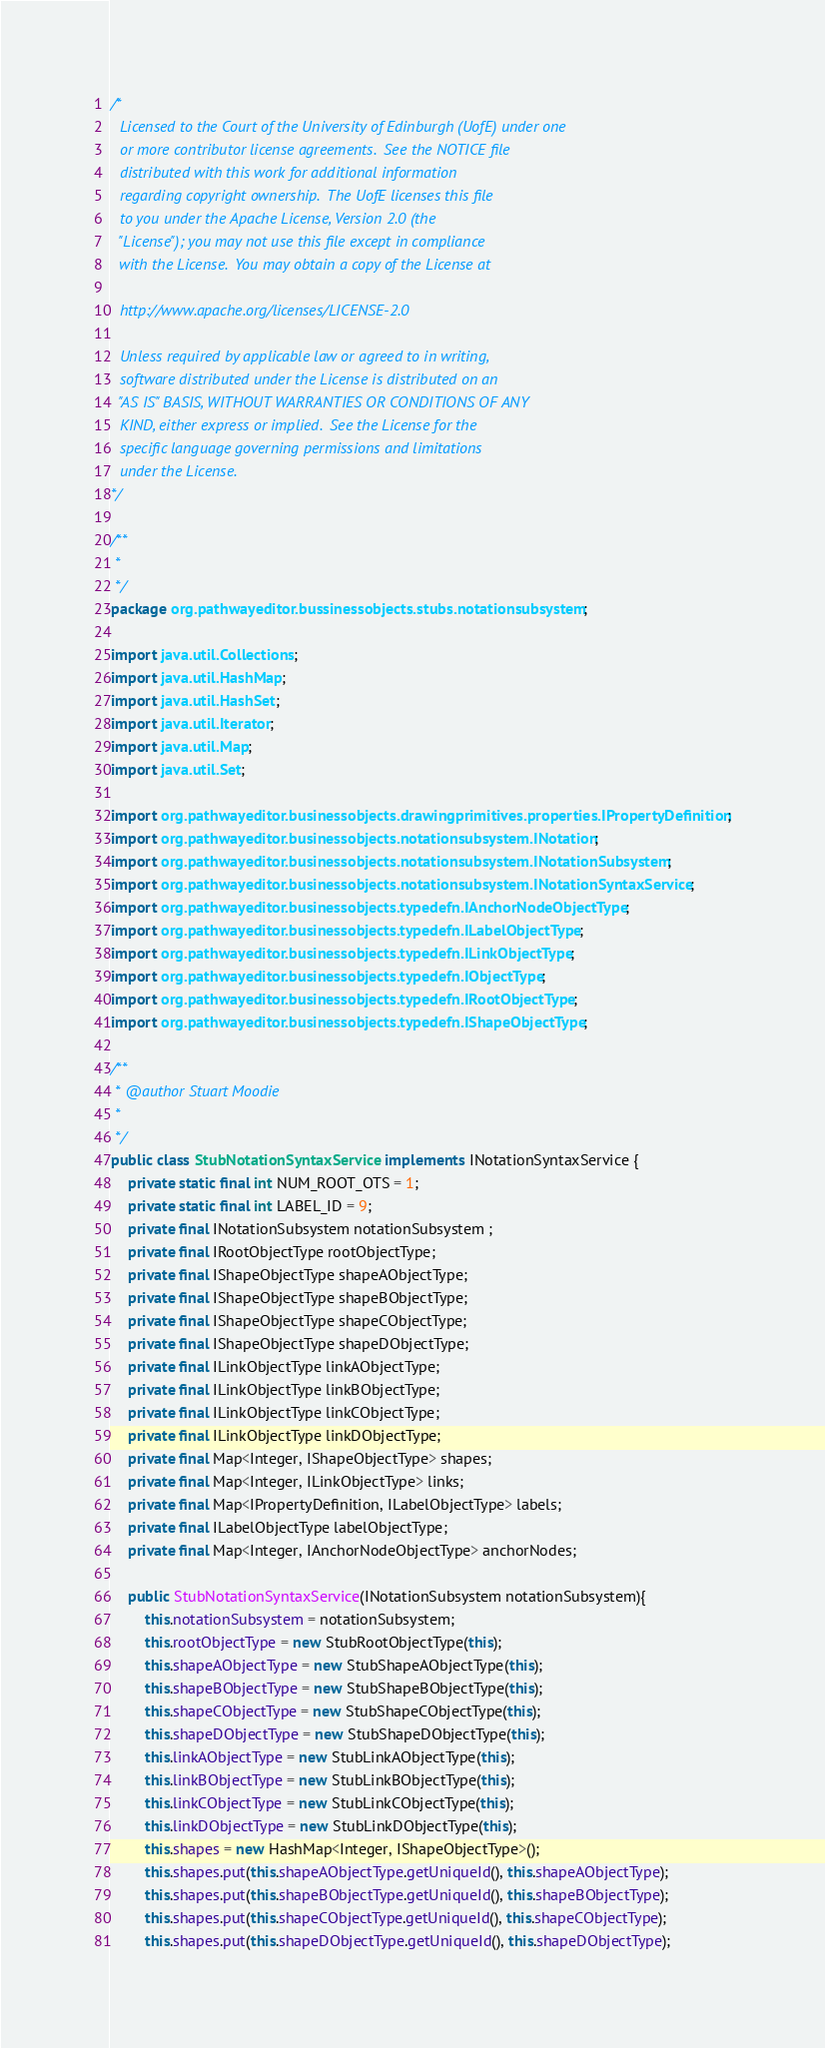Convert code to text. <code><loc_0><loc_0><loc_500><loc_500><_Java_>/*
  Licensed to the Court of the University of Edinburgh (UofE) under one
  or more contributor license agreements.  See the NOTICE file
  distributed with this work for additional information
  regarding copyright ownership.  The UofE licenses this file
  to you under the Apache License, Version 2.0 (the
  "License"); you may not use this file except in compliance
  with the License.  You may obtain a copy of the License at

  http://www.apache.org/licenses/LICENSE-2.0

  Unless required by applicable law or agreed to in writing,
  software distributed under the License is distributed on an
  "AS IS" BASIS, WITHOUT WARRANTIES OR CONDITIONS OF ANY
  KIND, either express or implied.  See the License for the
  specific language governing permissions and limitations
  under the License.
*/

/**
 * 
 */
package org.pathwayeditor.bussinessobjects.stubs.notationsubsystem;

import java.util.Collections;
import java.util.HashMap;
import java.util.HashSet;
import java.util.Iterator;
import java.util.Map;
import java.util.Set;

import org.pathwayeditor.businessobjects.drawingprimitives.properties.IPropertyDefinition;
import org.pathwayeditor.businessobjects.notationsubsystem.INotation;
import org.pathwayeditor.businessobjects.notationsubsystem.INotationSubsystem;
import org.pathwayeditor.businessobjects.notationsubsystem.INotationSyntaxService;
import org.pathwayeditor.businessobjects.typedefn.IAnchorNodeObjectType;
import org.pathwayeditor.businessobjects.typedefn.ILabelObjectType;
import org.pathwayeditor.businessobjects.typedefn.ILinkObjectType;
import org.pathwayeditor.businessobjects.typedefn.IObjectType;
import org.pathwayeditor.businessobjects.typedefn.IRootObjectType;
import org.pathwayeditor.businessobjects.typedefn.IShapeObjectType;

/**
 * @author Stuart Moodie
 *
 */
public class StubNotationSyntaxService implements INotationSyntaxService {
	private static final int NUM_ROOT_OTS = 1;
	private static final int LABEL_ID = 9;
	private final INotationSubsystem notationSubsystem ;
	private final IRootObjectType rootObjectType;
	private final IShapeObjectType shapeAObjectType;
	private final IShapeObjectType shapeBObjectType;
	private final IShapeObjectType shapeCObjectType;
	private final IShapeObjectType shapeDObjectType;
	private final ILinkObjectType linkAObjectType;
	private final ILinkObjectType linkBObjectType;
	private final ILinkObjectType linkCObjectType;
	private final ILinkObjectType linkDObjectType;
	private final Map<Integer, IShapeObjectType> shapes;
	private final Map<Integer, ILinkObjectType> links;
	private final Map<IPropertyDefinition, ILabelObjectType> labels;
	private final ILabelObjectType labelObjectType;
	private final Map<Integer, IAnchorNodeObjectType> anchorNodes;
	
	public StubNotationSyntaxService(INotationSubsystem notationSubsystem){
		this.notationSubsystem = notationSubsystem;
		this.rootObjectType = new StubRootObjectType(this);
		this.shapeAObjectType = new StubShapeAObjectType(this);
		this.shapeBObjectType = new StubShapeBObjectType(this);
		this.shapeCObjectType = new StubShapeCObjectType(this);
		this.shapeDObjectType = new StubShapeDObjectType(this);
		this.linkAObjectType = new StubLinkAObjectType(this);
		this.linkBObjectType = new StubLinkBObjectType(this);
		this.linkCObjectType = new StubLinkCObjectType(this);
		this.linkDObjectType = new StubLinkDObjectType(this);
		this.shapes = new HashMap<Integer, IShapeObjectType>();
		this.shapes.put(this.shapeAObjectType.getUniqueId(), this.shapeAObjectType);
		this.shapes.put(this.shapeBObjectType.getUniqueId(), this.shapeBObjectType);
		this.shapes.put(this.shapeCObjectType.getUniqueId(), this.shapeCObjectType);
		this.shapes.put(this.shapeDObjectType.getUniqueId(), this.shapeDObjectType);</code> 